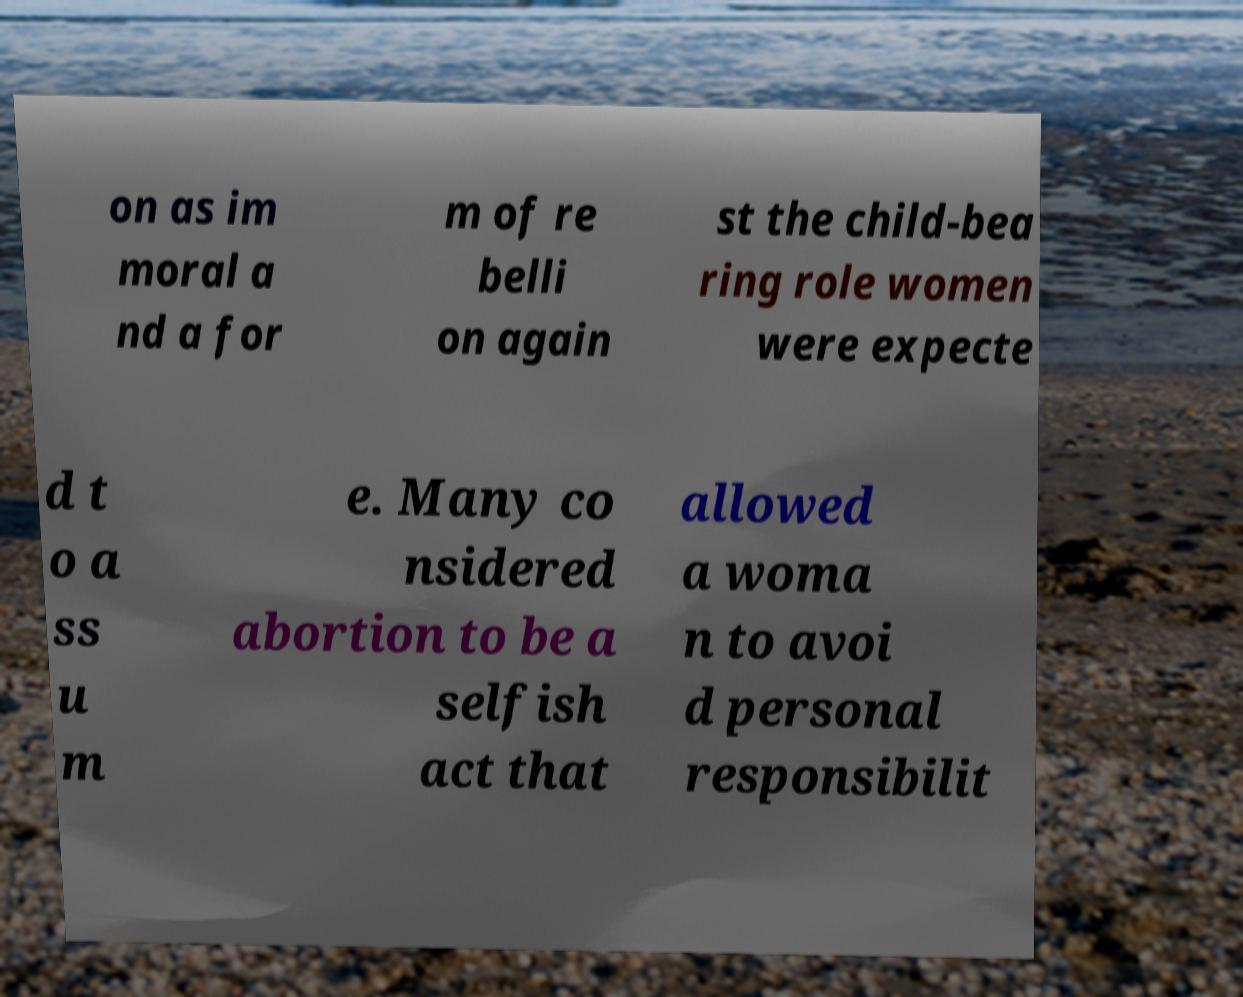Please read and relay the text visible in this image. What does it say? on as im moral a nd a for m of re belli on again st the child-bea ring role women were expecte d t o a ss u m e. Many co nsidered abortion to be a selfish act that allowed a woma n to avoi d personal responsibilit 